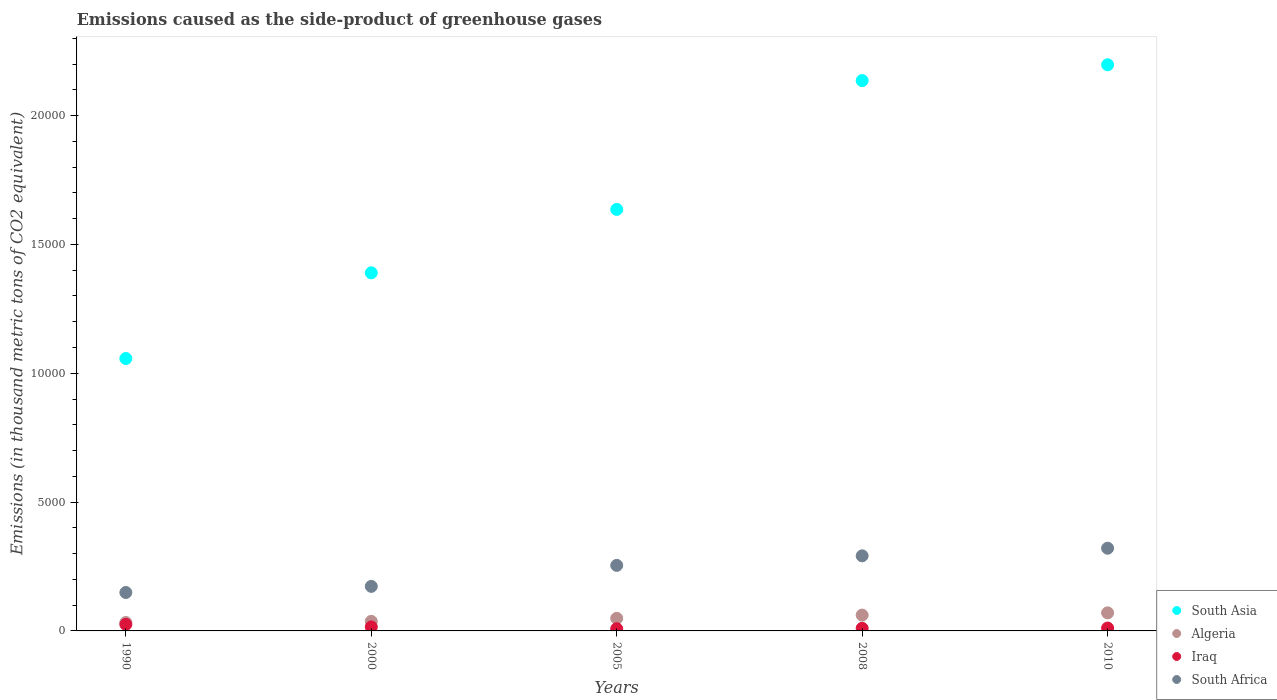Is the number of dotlines equal to the number of legend labels?
Provide a succinct answer. Yes. What is the emissions caused as the side-product of greenhouse gases in Algeria in 2000?
Give a very brief answer. 371.9. Across all years, what is the maximum emissions caused as the side-product of greenhouse gases in South Africa?
Your response must be concise. 3210. Across all years, what is the minimum emissions caused as the side-product of greenhouse gases in South Asia?
Your response must be concise. 1.06e+04. In which year was the emissions caused as the side-product of greenhouse gases in Algeria maximum?
Provide a succinct answer. 2010. In which year was the emissions caused as the side-product of greenhouse gases in Iraq minimum?
Your answer should be very brief. 2005. What is the total emissions caused as the side-product of greenhouse gases in Iraq in the graph?
Ensure brevity in your answer.  708.7. What is the difference between the emissions caused as the side-product of greenhouse gases in Iraq in 2000 and that in 2008?
Keep it short and to the point. 54.4. What is the difference between the emissions caused as the side-product of greenhouse gases in South Asia in 2005 and the emissions caused as the side-product of greenhouse gases in South Africa in 2010?
Your response must be concise. 1.31e+04. What is the average emissions caused as the side-product of greenhouse gases in South Asia per year?
Keep it short and to the point. 1.68e+04. In the year 1990, what is the difference between the emissions caused as the side-product of greenhouse gases in Algeria and emissions caused as the side-product of greenhouse gases in South Africa?
Keep it short and to the point. -1165.1. What is the ratio of the emissions caused as the side-product of greenhouse gases in Iraq in 2008 to that in 2010?
Your answer should be very brief. 0.91. Is the emissions caused as the side-product of greenhouse gases in South Asia in 2005 less than that in 2010?
Offer a very short reply. Yes. What is the difference between the highest and the second highest emissions caused as the side-product of greenhouse gases in Algeria?
Keep it short and to the point. 87.1. What is the difference between the highest and the lowest emissions caused as the side-product of greenhouse gases in South Africa?
Your response must be concise. 1718.9. Is it the case that in every year, the sum of the emissions caused as the side-product of greenhouse gases in Iraq and emissions caused as the side-product of greenhouse gases in South Asia  is greater than the emissions caused as the side-product of greenhouse gases in Algeria?
Provide a short and direct response. Yes. Does the emissions caused as the side-product of greenhouse gases in Algeria monotonically increase over the years?
Your answer should be very brief. Yes. Is the emissions caused as the side-product of greenhouse gases in South Asia strictly less than the emissions caused as the side-product of greenhouse gases in Algeria over the years?
Your response must be concise. No. How many dotlines are there?
Offer a terse response. 4. How many years are there in the graph?
Your answer should be very brief. 5. Are the values on the major ticks of Y-axis written in scientific E-notation?
Make the answer very short. No. Does the graph contain grids?
Offer a very short reply. No. How many legend labels are there?
Keep it short and to the point. 4. What is the title of the graph?
Your answer should be compact. Emissions caused as the side-product of greenhouse gases. What is the label or title of the X-axis?
Your answer should be compact. Years. What is the label or title of the Y-axis?
Make the answer very short. Emissions (in thousand metric tons of CO2 equivalent). What is the Emissions (in thousand metric tons of CO2 equivalent) in South Asia in 1990?
Your response must be concise. 1.06e+04. What is the Emissions (in thousand metric tons of CO2 equivalent) of Algeria in 1990?
Provide a short and direct response. 326. What is the Emissions (in thousand metric tons of CO2 equivalent) of Iraq in 1990?
Keep it short and to the point. 252.9. What is the Emissions (in thousand metric tons of CO2 equivalent) in South Africa in 1990?
Provide a short and direct response. 1491.1. What is the Emissions (in thousand metric tons of CO2 equivalent) of South Asia in 2000?
Offer a terse response. 1.39e+04. What is the Emissions (in thousand metric tons of CO2 equivalent) of Algeria in 2000?
Keep it short and to the point. 371.9. What is the Emissions (in thousand metric tons of CO2 equivalent) of Iraq in 2000?
Offer a terse response. 156.1. What is the Emissions (in thousand metric tons of CO2 equivalent) of South Africa in 2000?
Offer a terse response. 1728.8. What is the Emissions (in thousand metric tons of CO2 equivalent) of South Asia in 2005?
Provide a succinct answer. 1.64e+04. What is the Emissions (in thousand metric tons of CO2 equivalent) of Algeria in 2005?
Your answer should be compact. 487.4. What is the Emissions (in thousand metric tons of CO2 equivalent) of Iraq in 2005?
Make the answer very short. 86. What is the Emissions (in thousand metric tons of CO2 equivalent) of South Africa in 2005?
Your response must be concise. 2544. What is the Emissions (in thousand metric tons of CO2 equivalent) of South Asia in 2008?
Offer a terse response. 2.14e+04. What is the Emissions (in thousand metric tons of CO2 equivalent) in Algeria in 2008?
Offer a very short reply. 613.9. What is the Emissions (in thousand metric tons of CO2 equivalent) of Iraq in 2008?
Your response must be concise. 101.7. What is the Emissions (in thousand metric tons of CO2 equivalent) of South Africa in 2008?
Keep it short and to the point. 2914.4. What is the Emissions (in thousand metric tons of CO2 equivalent) of South Asia in 2010?
Offer a terse response. 2.20e+04. What is the Emissions (in thousand metric tons of CO2 equivalent) of Algeria in 2010?
Offer a terse response. 701. What is the Emissions (in thousand metric tons of CO2 equivalent) of Iraq in 2010?
Provide a succinct answer. 112. What is the Emissions (in thousand metric tons of CO2 equivalent) of South Africa in 2010?
Offer a terse response. 3210. Across all years, what is the maximum Emissions (in thousand metric tons of CO2 equivalent) in South Asia?
Your answer should be compact. 2.20e+04. Across all years, what is the maximum Emissions (in thousand metric tons of CO2 equivalent) of Algeria?
Offer a terse response. 701. Across all years, what is the maximum Emissions (in thousand metric tons of CO2 equivalent) of Iraq?
Keep it short and to the point. 252.9. Across all years, what is the maximum Emissions (in thousand metric tons of CO2 equivalent) of South Africa?
Your response must be concise. 3210. Across all years, what is the minimum Emissions (in thousand metric tons of CO2 equivalent) in South Asia?
Provide a short and direct response. 1.06e+04. Across all years, what is the minimum Emissions (in thousand metric tons of CO2 equivalent) in Algeria?
Your answer should be compact. 326. Across all years, what is the minimum Emissions (in thousand metric tons of CO2 equivalent) in Iraq?
Keep it short and to the point. 86. Across all years, what is the minimum Emissions (in thousand metric tons of CO2 equivalent) in South Africa?
Your answer should be very brief. 1491.1. What is the total Emissions (in thousand metric tons of CO2 equivalent) of South Asia in the graph?
Offer a terse response. 8.42e+04. What is the total Emissions (in thousand metric tons of CO2 equivalent) in Algeria in the graph?
Provide a succinct answer. 2500.2. What is the total Emissions (in thousand metric tons of CO2 equivalent) in Iraq in the graph?
Keep it short and to the point. 708.7. What is the total Emissions (in thousand metric tons of CO2 equivalent) of South Africa in the graph?
Offer a very short reply. 1.19e+04. What is the difference between the Emissions (in thousand metric tons of CO2 equivalent) in South Asia in 1990 and that in 2000?
Provide a short and direct response. -3325.3. What is the difference between the Emissions (in thousand metric tons of CO2 equivalent) of Algeria in 1990 and that in 2000?
Make the answer very short. -45.9. What is the difference between the Emissions (in thousand metric tons of CO2 equivalent) in Iraq in 1990 and that in 2000?
Keep it short and to the point. 96.8. What is the difference between the Emissions (in thousand metric tons of CO2 equivalent) in South Africa in 1990 and that in 2000?
Your answer should be compact. -237.7. What is the difference between the Emissions (in thousand metric tons of CO2 equivalent) in South Asia in 1990 and that in 2005?
Offer a very short reply. -5786.5. What is the difference between the Emissions (in thousand metric tons of CO2 equivalent) of Algeria in 1990 and that in 2005?
Keep it short and to the point. -161.4. What is the difference between the Emissions (in thousand metric tons of CO2 equivalent) of Iraq in 1990 and that in 2005?
Your answer should be compact. 166.9. What is the difference between the Emissions (in thousand metric tons of CO2 equivalent) in South Africa in 1990 and that in 2005?
Provide a succinct answer. -1052.9. What is the difference between the Emissions (in thousand metric tons of CO2 equivalent) of South Asia in 1990 and that in 2008?
Give a very brief answer. -1.08e+04. What is the difference between the Emissions (in thousand metric tons of CO2 equivalent) of Algeria in 1990 and that in 2008?
Provide a short and direct response. -287.9. What is the difference between the Emissions (in thousand metric tons of CO2 equivalent) of Iraq in 1990 and that in 2008?
Your answer should be compact. 151.2. What is the difference between the Emissions (in thousand metric tons of CO2 equivalent) of South Africa in 1990 and that in 2008?
Make the answer very short. -1423.3. What is the difference between the Emissions (in thousand metric tons of CO2 equivalent) in South Asia in 1990 and that in 2010?
Give a very brief answer. -1.14e+04. What is the difference between the Emissions (in thousand metric tons of CO2 equivalent) in Algeria in 1990 and that in 2010?
Offer a terse response. -375. What is the difference between the Emissions (in thousand metric tons of CO2 equivalent) of Iraq in 1990 and that in 2010?
Give a very brief answer. 140.9. What is the difference between the Emissions (in thousand metric tons of CO2 equivalent) of South Africa in 1990 and that in 2010?
Provide a short and direct response. -1718.9. What is the difference between the Emissions (in thousand metric tons of CO2 equivalent) of South Asia in 2000 and that in 2005?
Your answer should be compact. -2461.2. What is the difference between the Emissions (in thousand metric tons of CO2 equivalent) of Algeria in 2000 and that in 2005?
Your response must be concise. -115.5. What is the difference between the Emissions (in thousand metric tons of CO2 equivalent) of Iraq in 2000 and that in 2005?
Make the answer very short. 70.1. What is the difference between the Emissions (in thousand metric tons of CO2 equivalent) in South Africa in 2000 and that in 2005?
Ensure brevity in your answer.  -815.2. What is the difference between the Emissions (in thousand metric tons of CO2 equivalent) in South Asia in 2000 and that in 2008?
Offer a terse response. -7460.6. What is the difference between the Emissions (in thousand metric tons of CO2 equivalent) in Algeria in 2000 and that in 2008?
Offer a very short reply. -242. What is the difference between the Emissions (in thousand metric tons of CO2 equivalent) in Iraq in 2000 and that in 2008?
Provide a short and direct response. 54.4. What is the difference between the Emissions (in thousand metric tons of CO2 equivalent) of South Africa in 2000 and that in 2008?
Your response must be concise. -1185.6. What is the difference between the Emissions (in thousand metric tons of CO2 equivalent) in South Asia in 2000 and that in 2010?
Offer a very short reply. -8075.1. What is the difference between the Emissions (in thousand metric tons of CO2 equivalent) of Algeria in 2000 and that in 2010?
Keep it short and to the point. -329.1. What is the difference between the Emissions (in thousand metric tons of CO2 equivalent) of Iraq in 2000 and that in 2010?
Give a very brief answer. 44.1. What is the difference between the Emissions (in thousand metric tons of CO2 equivalent) in South Africa in 2000 and that in 2010?
Offer a very short reply. -1481.2. What is the difference between the Emissions (in thousand metric tons of CO2 equivalent) of South Asia in 2005 and that in 2008?
Offer a terse response. -4999.4. What is the difference between the Emissions (in thousand metric tons of CO2 equivalent) of Algeria in 2005 and that in 2008?
Your answer should be compact. -126.5. What is the difference between the Emissions (in thousand metric tons of CO2 equivalent) of Iraq in 2005 and that in 2008?
Your answer should be compact. -15.7. What is the difference between the Emissions (in thousand metric tons of CO2 equivalent) in South Africa in 2005 and that in 2008?
Provide a succinct answer. -370.4. What is the difference between the Emissions (in thousand metric tons of CO2 equivalent) in South Asia in 2005 and that in 2010?
Your answer should be compact. -5613.9. What is the difference between the Emissions (in thousand metric tons of CO2 equivalent) of Algeria in 2005 and that in 2010?
Offer a terse response. -213.6. What is the difference between the Emissions (in thousand metric tons of CO2 equivalent) of South Africa in 2005 and that in 2010?
Make the answer very short. -666. What is the difference between the Emissions (in thousand metric tons of CO2 equivalent) of South Asia in 2008 and that in 2010?
Your answer should be very brief. -614.5. What is the difference between the Emissions (in thousand metric tons of CO2 equivalent) of Algeria in 2008 and that in 2010?
Your answer should be compact. -87.1. What is the difference between the Emissions (in thousand metric tons of CO2 equivalent) of Iraq in 2008 and that in 2010?
Provide a succinct answer. -10.3. What is the difference between the Emissions (in thousand metric tons of CO2 equivalent) of South Africa in 2008 and that in 2010?
Your answer should be compact. -295.6. What is the difference between the Emissions (in thousand metric tons of CO2 equivalent) of South Asia in 1990 and the Emissions (in thousand metric tons of CO2 equivalent) of Algeria in 2000?
Your answer should be compact. 1.02e+04. What is the difference between the Emissions (in thousand metric tons of CO2 equivalent) in South Asia in 1990 and the Emissions (in thousand metric tons of CO2 equivalent) in Iraq in 2000?
Provide a short and direct response. 1.04e+04. What is the difference between the Emissions (in thousand metric tons of CO2 equivalent) in South Asia in 1990 and the Emissions (in thousand metric tons of CO2 equivalent) in South Africa in 2000?
Provide a succinct answer. 8843.8. What is the difference between the Emissions (in thousand metric tons of CO2 equivalent) in Algeria in 1990 and the Emissions (in thousand metric tons of CO2 equivalent) in Iraq in 2000?
Ensure brevity in your answer.  169.9. What is the difference between the Emissions (in thousand metric tons of CO2 equivalent) of Algeria in 1990 and the Emissions (in thousand metric tons of CO2 equivalent) of South Africa in 2000?
Keep it short and to the point. -1402.8. What is the difference between the Emissions (in thousand metric tons of CO2 equivalent) in Iraq in 1990 and the Emissions (in thousand metric tons of CO2 equivalent) in South Africa in 2000?
Keep it short and to the point. -1475.9. What is the difference between the Emissions (in thousand metric tons of CO2 equivalent) of South Asia in 1990 and the Emissions (in thousand metric tons of CO2 equivalent) of Algeria in 2005?
Provide a succinct answer. 1.01e+04. What is the difference between the Emissions (in thousand metric tons of CO2 equivalent) in South Asia in 1990 and the Emissions (in thousand metric tons of CO2 equivalent) in Iraq in 2005?
Your response must be concise. 1.05e+04. What is the difference between the Emissions (in thousand metric tons of CO2 equivalent) in South Asia in 1990 and the Emissions (in thousand metric tons of CO2 equivalent) in South Africa in 2005?
Your answer should be very brief. 8028.6. What is the difference between the Emissions (in thousand metric tons of CO2 equivalent) in Algeria in 1990 and the Emissions (in thousand metric tons of CO2 equivalent) in Iraq in 2005?
Your answer should be compact. 240. What is the difference between the Emissions (in thousand metric tons of CO2 equivalent) in Algeria in 1990 and the Emissions (in thousand metric tons of CO2 equivalent) in South Africa in 2005?
Ensure brevity in your answer.  -2218. What is the difference between the Emissions (in thousand metric tons of CO2 equivalent) of Iraq in 1990 and the Emissions (in thousand metric tons of CO2 equivalent) of South Africa in 2005?
Offer a very short reply. -2291.1. What is the difference between the Emissions (in thousand metric tons of CO2 equivalent) in South Asia in 1990 and the Emissions (in thousand metric tons of CO2 equivalent) in Algeria in 2008?
Your answer should be very brief. 9958.7. What is the difference between the Emissions (in thousand metric tons of CO2 equivalent) of South Asia in 1990 and the Emissions (in thousand metric tons of CO2 equivalent) of Iraq in 2008?
Provide a succinct answer. 1.05e+04. What is the difference between the Emissions (in thousand metric tons of CO2 equivalent) of South Asia in 1990 and the Emissions (in thousand metric tons of CO2 equivalent) of South Africa in 2008?
Provide a short and direct response. 7658.2. What is the difference between the Emissions (in thousand metric tons of CO2 equivalent) of Algeria in 1990 and the Emissions (in thousand metric tons of CO2 equivalent) of Iraq in 2008?
Ensure brevity in your answer.  224.3. What is the difference between the Emissions (in thousand metric tons of CO2 equivalent) in Algeria in 1990 and the Emissions (in thousand metric tons of CO2 equivalent) in South Africa in 2008?
Provide a succinct answer. -2588.4. What is the difference between the Emissions (in thousand metric tons of CO2 equivalent) in Iraq in 1990 and the Emissions (in thousand metric tons of CO2 equivalent) in South Africa in 2008?
Give a very brief answer. -2661.5. What is the difference between the Emissions (in thousand metric tons of CO2 equivalent) of South Asia in 1990 and the Emissions (in thousand metric tons of CO2 equivalent) of Algeria in 2010?
Offer a terse response. 9871.6. What is the difference between the Emissions (in thousand metric tons of CO2 equivalent) in South Asia in 1990 and the Emissions (in thousand metric tons of CO2 equivalent) in Iraq in 2010?
Make the answer very short. 1.05e+04. What is the difference between the Emissions (in thousand metric tons of CO2 equivalent) of South Asia in 1990 and the Emissions (in thousand metric tons of CO2 equivalent) of South Africa in 2010?
Your response must be concise. 7362.6. What is the difference between the Emissions (in thousand metric tons of CO2 equivalent) in Algeria in 1990 and the Emissions (in thousand metric tons of CO2 equivalent) in Iraq in 2010?
Offer a terse response. 214. What is the difference between the Emissions (in thousand metric tons of CO2 equivalent) of Algeria in 1990 and the Emissions (in thousand metric tons of CO2 equivalent) of South Africa in 2010?
Give a very brief answer. -2884. What is the difference between the Emissions (in thousand metric tons of CO2 equivalent) of Iraq in 1990 and the Emissions (in thousand metric tons of CO2 equivalent) of South Africa in 2010?
Ensure brevity in your answer.  -2957.1. What is the difference between the Emissions (in thousand metric tons of CO2 equivalent) in South Asia in 2000 and the Emissions (in thousand metric tons of CO2 equivalent) in Algeria in 2005?
Your answer should be compact. 1.34e+04. What is the difference between the Emissions (in thousand metric tons of CO2 equivalent) in South Asia in 2000 and the Emissions (in thousand metric tons of CO2 equivalent) in Iraq in 2005?
Your answer should be compact. 1.38e+04. What is the difference between the Emissions (in thousand metric tons of CO2 equivalent) of South Asia in 2000 and the Emissions (in thousand metric tons of CO2 equivalent) of South Africa in 2005?
Give a very brief answer. 1.14e+04. What is the difference between the Emissions (in thousand metric tons of CO2 equivalent) of Algeria in 2000 and the Emissions (in thousand metric tons of CO2 equivalent) of Iraq in 2005?
Ensure brevity in your answer.  285.9. What is the difference between the Emissions (in thousand metric tons of CO2 equivalent) in Algeria in 2000 and the Emissions (in thousand metric tons of CO2 equivalent) in South Africa in 2005?
Your response must be concise. -2172.1. What is the difference between the Emissions (in thousand metric tons of CO2 equivalent) in Iraq in 2000 and the Emissions (in thousand metric tons of CO2 equivalent) in South Africa in 2005?
Your response must be concise. -2387.9. What is the difference between the Emissions (in thousand metric tons of CO2 equivalent) of South Asia in 2000 and the Emissions (in thousand metric tons of CO2 equivalent) of Algeria in 2008?
Keep it short and to the point. 1.33e+04. What is the difference between the Emissions (in thousand metric tons of CO2 equivalent) in South Asia in 2000 and the Emissions (in thousand metric tons of CO2 equivalent) in Iraq in 2008?
Your answer should be very brief. 1.38e+04. What is the difference between the Emissions (in thousand metric tons of CO2 equivalent) in South Asia in 2000 and the Emissions (in thousand metric tons of CO2 equivalent) in South Africa in 2008?
Your answer should be very brief. 1.10e+04. What is the difference between the Emissions (in thousand metric tons of CO2 equivalent) in Algeria in 2000 and the Emissions (in thousand metric tons of CO2 equivalent) in Iraq in 2008?
Your answer should be compact. 270.2. What is the difference between the Emissions (in thousand metric tons of CO2 equivalent) in Algeria in 2000 and the Emissions (in thousand metric tons of CO2 equivalent) in South Africa in 2008?
Your response must be concise. -2542.5. What is the difference between the Emissions (in thousand metric tons of CO2 equivalent) in Iraq in 2000 and the Emissions (in thousand metric tons of CO2 equivalent) in South Africa in 2008?
Your answer should be compact. -2758.3. What is the difference between the Emissions (in thousand metric tons of CO2 equivalent) of South Asia in 2000 and the Emissions (in thousand metric tons of CO2 equivalent) of Algeria in 2010?
Your answer should be compact. 1.32e+04. What is the difference between the Emissions (in thousand metric tons of CO2 equivalent) of South Asia in 2000 and the Emissions (in thousand metric tons of CO2 equivalent) of Iraq in 2010?
Keep it short and to the point. 1.38e+04. What is the difference between the Emissions (in thousand metric tons of CO2 equivalent) in South Asia in 2000 and the Emissions (in thousand metric tons of CO2 equivalent) in South Africa in 2010?
Your response must be concise. 1.07e+04. What is the difference between the Emissions (in thousand metric tons of CO2 equivalent) in Algeria in 2000 and the Emissions (in thousand metric tons of CO2 equivalent) in Iraq in 2010?
Keep it short and to the point. 259.9. What is the difference between the Emissions (in thousand metric tons of CO2 equivalent) in Algeria in 2000 and the Emissions (in thousand metric tons of CO2 equivalent) in South Africa in 2010?
Make the answer very short. -2838.1. What is the difference between the Emissions (in thousand metric tons of CO2 equivalent) of Iraq in 2000 and the Emissions (in thousand metric tons of CO2 equivalent) of South Africa in 2010?
Offer a terse response. -3053.9. What is the difference between the Emissions (in thousand metric tons of CO2 equivalent) of South Asia in 2005 and the Emissions (in thousand metric tons of CO2 equivalent) of Algeria in 2008?
Your answer should be very brief. 1.57e+04. What is the difference between the Emissions (in thousand metric tons of CO2 equivalent) in South Asia in 2005 and the Emissions (in thousand metric tons of CO2 equivalent) in Iraq in 2008?
Offer a very short reply. 1.63e+04. What is the difference between the Emissions (in thousand metric tons of CO2 equivalent) in South Asia in 2005 and the Emissions (in thousand metric tons of CO2 equivalent) in South Africa in 2008?
Keep it short and to the point. 1.34e+04. What is the difference between the Emissions (in thousand metric tons of CO2 equivalent) of Algeria in 2005 and the Emissions (in thousand metric tons of CO2 equivalent) of Iraq in 2008?
Ensure brevity in your answer.  385.7. What is the difference between the Emissions (in thousand metric tons of CO2 equivalent) of Algeria in 2005 and the Emissions (in thousand metric tons of CO2 equivalent) of South Africa in 2008?
Keep it short and to the point. -2427. What is the difference between the Emissions (in thousand metric tons of CO2 equivalent) of Iraq in 2005 and the Emissions (in thousand metric tons of CO2 equivalent) of South Africa in 2008?
Your answer should be compact. -2828.4. What is the difference between the Emissions (in thousand metric tons of CO2 equivalent) in South Asia in 2005 and the Emissions (in thousand metric tons of CO2 equivalent) in Algeria in 2010?
Give a very brief answer. 1.57e+04. What is the difference between the Emissions (in thousand metric tons of CO2 equivalent) in South Asia in 2005 and the Emissions (in thousand metric tons of CO2 equivalent) in Iraq in 2010?
Provide a succinct answer. 1.62e+04. What is the difference between the Emissions (in thousand metric tons of CO2 equivalent) in South Asia in 2005 and the Emissions (in thousand metric tons of CO2 equivalent) in South Africa in 2010?
Make the answer very short. 1.31e+04. What is the difference between the Emissions (in thousand metric tons of CO2 equivalent) of Algeria in 2005 and the Emissions (in thousand metric tons of CO2 equivalent) of Iraq in 2010?
Offer a very short reply. 375.4. What is the difference between the Emissions (in thousand metric tons of CO2 equivalent) in Algeria in 2005 and the Emissions (in thousand metric tons of CO2 equivalent) in South Africa in 2010?
Ensure brevity in your answer.  -2722.6. What is the difference between the Emissions (in thousand metric tons of CO2 equivalent) in Iraq in 2005 and the Emissions (in thousand metric tons of CO2 equivalent) in South Africa in 2010?
Give a very brief answer. -3124. What is the difference between the Emissions (in thousand metric tons of CO2 equivalent) in South Asia in 2008 and the Emissions (in thousand metric tons of CO2 equivalent) in Algeria in 2010?
Offer a terse response. 2.07e+04. What is the difference between the Emissions (in thousand metric tons of CO2 equivalent) in South Asia in 2008 and the Emissions (in thousand metric tons of CO2 equivalent) in Iraq in 2010?
Offer a terse response. 2.12e+04. What is the difference between the Emissions (in thousand metric tons of CO2 equivalent) of South Asia in 2008 and the Emissions (in thousand metric tons of CO2 equivalent) of South Africa in 2010?
Your answer should be very brief. 1.81e+04. What is the difference between the Emissions (in thousand metric tons of CO2 equivalent) in Algeria in 2008 and the Emissions (in thousand metric tons of CO2 equivalent) in Iraq in 2010?
Offer a terse response. 501.9. What is the difference between the Emissions (in thousand metric tons of CO2 equivalent) in Algeria in 2008 and the Emissions (in thousand metric tons of CO2 equivalent) in South Africa in 2010?
Offer a very short reply. -2596.1. What is the difference between the Emissions (in thousand metric tons of CO2 equivalent) in Iraq in 2008 and the Emissions (in thousand metric tons of CO2 equivalent) in South Africa in 2010?
Your answer should be compact. -3108.3. What is the average Emissions (in thousand metric tons of CO2 equivalent) of South Asia per year?
Keep it short and to the point. 1.68e+04. What is the average Emissions (in thousand metric tons of CO2 equivalent) of Algeria per year?
Provide a succinct answer. 500.04. What is the average Emissions (in thousand metric tons of CO2 equivalent) of Iraq per year?
Provide a short and direct response. 141.74. What is the average Emissions (in thousand metric tons of CO2 equivalent) in South Africa per year?
Keep it short and to the point. 2377.66. In the year 1990, what is the difference between the Emissions (in thousand metric tons of CO2 equivalent) in South Asia and Emissions (in thousand metric tons of CO2 equivalent) in Algeria?
Your answer should be very brief. 1.02e+04. In the year 1990, what is the difference between the Emissions (in thousand metric tons of CO2 equivalent) in South Asia and Emissions (in thousand metric tons of CO2 equivalent) in Iraq?
Make the answer very short. 1.03e+04. In the year 1990, what is the difference between the Emissions (in thousand metric tons of CO2 equivalent) of South Asia and Emissions (in thousand metric tons of CO2 equivalent) of South Africa?
Provide a short and direct response. 9081.5. In the year 1990, what is the difference between the Emissions (in thousand metric tons of CO2 equivalent) of Algeria and Emissions (in thousand metric tons of CO2 equivalent) of Iraq?
Ensure brevity in your answer.  73.1. In the year 1990, what is the difference between the Emissions (in thousand metric tons of CO2 equivalent) of Algeria and Emissions (in thousand metric tons of CO2 equivalent) of South Africa?
Offer a terse response. -1165.1. In the year 1990, what is the difference between the Emissions (in thousand metric tons of CO2 equivalent) in Iraq and Emissions (in thousand metric tons of CO2 equivalent) in South Africa?
Provide a succinct answer. -1238.2. In the year 2000, what is the difference between the Emissions (in thousand metric tons of CO2 equivalent) in South Asia and Emissions (in thousand metric tons of CO2 equivalent) in Algeria?
Your response must be concise. 1.35e+04. In the year 2000, what is the difference between the Emissions (in thousand metric tons of CO2 equivalent) of South Asia and Emissions (in thousand metric tons of CO2 equivalent) of Iraq?
Give a very brief answer. 1.37e+04. In the year 2000, what is the difference between the Emissions (in thousand metric tons of CO2 equivalent) in South Asia and Emissions (in thousand metric tons of CO2 equivalent) in South Africa?
Ensure brevity in your answer.  1.22e+04. In the year 2000, what is the difference between the Emissions (in thousand metric tons of CO2 equivalent) in Algeria and Emissions (in thousand metric tons of CO2 equivalent) in Iraq?
Keep it short and to the point. 215.8. In the year 2000, what is the difference between the Emissions (in thousand metric tons of CO2 equivalent) in Algeria and Emissions (in thousand metric tons of CO2 equivalent) in South Africa?
Your answer should be compact. -1356.9. In the year 2000, what is the difference between the Emissions (in thousand metric tons of CO2 equivalent) of Iraq and Emissions (in thousand metric tons of CO2 equivalent) of South Africa?
Provide a short and direct response. -1572.7. In the year 2005, what is the difference between the Emissions (in thousand metric tons of CO2 equivalent) of South Asia and Emissions (in thousand metric tons of CO2 equivalent) of Algeria?
Ensure brevity in your answer.  1.59e+04. In the year 2005, what is the difference between the Emissions (in thousand metric tons of CO2 equivalent) in South Asia and Emissions (in thousand metric tons of CO2 equivalent) in Iraq?
Make the answer very short. 1.63e+04. In the year 2005, what is the difference between the Emissions (in thousand metric tons of CO2 equivalent) of South Asia and Emissions (in thousand metric tons of CO2 equivalent) of South Africa?
Offer a terse response. 1.38e+04. In the year 2005, what is the difference between the Emissions (in thousand metric tons of CO2 equivalent) in Algeria and Emissions (in thousand metric tons of CO2 equivalent) in Iraq?
Your answer should be very brief. 401.4. In the year 2005, what is the difference between the Emissions (in thousand metric tons of CO2 equivalent) of Algeria and Emissions (in thousand metric tons of CO2 equivalent) of South Africa?
Your answer should be very brief. -2056.6. In the year 2005, what is the difference between the Emissions (in thousand metric tons of CO2 equivalent) in Iraq and Emissions (in thousand metric tons of CO2 equivalent) in South Africa?
Keep it short and to the point. -2458. In the year 2008, what is the difference between the Emissions (in thousand metric tons of CO2 equivalent) in South Asia and Emissions (in thousand metric tons of CO2 equivalent) in Algeria?
Keep it short and to the point. 2.07e+04. In the year 2008, what is the difference between the Emissions (in thousand metric tons of CO2 equivalent) of South Asia and Emissions (in thousand metric tons of CO2 equivalent) of Iraq?
Offer a very short reply. 2.13e+04. In the year 2008, what is the difference between the Emissions (in thousand metric tons of CO2 equivalent) of South Asia and Emissions (in thousand metric tons of CO2 equivalent) of South Africa?
Ensure brevity in your answer.  1.84e+04. In the year 2008, what is the difference between the Emissions (in thousand metric tons of CO2 equivalent) of Algeria and Emissions (in thousand metric tons of CO2 equivalent) of Iraq?
Provide a succinct answer. 512.2. In the year 2008, what is the difference between the Emissions (in thousand metric tons of CO2 equivalent) of Algeria and Emissions (in thousand metric tons of CO2 equivalent) of South Africa?
Give a very brief answer. -2300.5. In the year 2008, what is the difference between the Emissions (in thousand metric tons of CO2 equivalent) in Iraq and Emissions (in thousand metric tons of CO2 equivalent) in South Africa?
Your answer should be compact. -2812.7. In the year 2010, what is the difference between the Emissions (in thousand metric tons of CO2 equivalent) in South Asia and Emissions (in thousand metric tons of CO2 equivalent) in Algeria?
Your response must be concise. 2.13e+04. In the year 2010, what is the difference between the Emissions (in thousand metric tons of CO2 equivalent) of South Asia and Emissions (in thousand metric tons of CO2 equivalent) of Iraq?
Ensure brevity in your answer.  2.19e+04. In the year 2010, what is the difference between the Emissions (in thousand metric tons of CO2 equivalent) of South Asia and Emissions (in thousand metric tons of CO2 equivalent) of South Africa?
Provide a succinct answer. 1.88e+04. In the year 2010, what is the difference between the Emissions (in thousand metric tons of CO2 equivalent) in Algeria and Emissions (in thousand metric tons of CO2 equivalent) in Iraq?
Make the answer very short. 589. In the year 2010, what is the difference between the Emissions (in thousand metric tons of CO2 equivalent) of Algeria and Emissions (in thousand metric tons of CO2 equivalent) of South Africa?
Your response must be concise. -2509. In the year 2010, what is the difference between the Emissions (in thousand metric tons of CO2 equivalent) in Iraq and Emissions (in thousand metric tons of CO2 equivalent) in South Africa?
Make the answer very short. -3098. What is the ratio of the Emissions (in thousand metric tons of CO2 equivalent) of South Asia in 1990 to that in 2000?
Your answer should be very brief. 0.76. What is the ratio of the Emissions (in thousand metric tons of CO2 equivalent) in Algeria in 1990 to that in 2000?
Your response must be concise. 0.88. What is the ratio of the Emissions (in thousand metric tons of CO2 equivalent) of Iraq in 1990 to that in 2000?
Provide a succinct answer. 1.62. What is the ratio of the Emissions (in thousand metric tons of CO2 equivalent) in South Africa in 1990 to that in 2000?
Make the answer very short. 0.86. What is the ratio of the Emissions (in thousand metric tons of CO2 equivalent) in South Asia in 1990 to that in 2005?
Ensure brevity in your answer.  0.65. What is the ratio of the Emissions (in thousand metric tons of CO2 equivalent) in Algeria in 1990 to that in 2005?
Ensure brevity in your answer.  0.67. What is the ratio of the Emissions (in thousand metric tons of CO2 equivalent) of Iraq in 1990 to that in 2005?
Your response must be concise. 2.94. What is the ratio of the Emissions (in thousand metric tons of CO2 equivalent) in South Africa in 1990 to that in 2005?
Keep it short and to the point. 0.59. What is the ratio of the Emissions (in thousand metric tons of CO2 equivalent) in South Asia in 1990 to that in 2008?
Your answer should be very brief. 0.49. What is the ratio of the Emissions (in thousand metric tons of CO2 equivalent) of Algeria in 1990 to that in 2008?
Make the answer very short. 0.53. What is the ratio of the Emissions (in thousand metric tons of CO2 equivalent) in Iraq in 1990 to that in 2008?
Offer a terse response. 2.49. What is the ratio of the Emissions (in thousand metric tons of CO2 equivalent) in South Africa in 1990 to that in 2008?
Offer a very short reply. 0.51. What is the ratio of the Emissions (in thousand metric tons of CO2 equivalent) of South Asia in 1990 to that in 2010?
Provide a short and direct response. 0.48. What is the ratio of the Emissions (in thousand metric tons of CO2 equivalent) of Algeria in 1990 to that in 2010?
Make the answer very short. 0.47. What is the ratio of the Emissions (in thousand metric tons of CO2 equivalent) in Iraq in 1990 to that in 2010?
Your answer should be very brief. 2.26. What is the ratio of the Emissions (in thousand metric tons of CO2 equivalent) in South Africa in 1990 to that in 2010?
Provide a short and direct response. 0.46. What is the ratio of the Emissions (in thousand metric tons of CO2 equivalent) in South Asia in 2000 to that in 2005?
Your response must be concise. 0.85. What is the ratio of the Emissions (in thousand metric tons of CO2 equivalent) of Algeria in 2000 to that in 2005?
Your response must be concise. 0.76. What is the ratio of the Emissions (in thousand metric tons of CO2 equivalent) of Iraq in 2000 to that in 2005?
Offer a very short reply. 1.82. What is the ratio of the Emissions (in thousand metric tons of CO2 equivalent) in South Africa in 2000 to that in 2005?
Offer a terse response. 0.68. What is the ratio of the Emissions (in thousand metric tons of CO2 equivalent) in South Asia in 2000 to that in 2008?
Offer a terse response. 0.65. What is the ratio of the Emissions (in thousand metric tons of CO2 equivalent) of Algeria in 2000 to that in 2008?
Provide a succinct answer. 0.61. What is the ratio of the Emissions (in thousand metric tons of CO2 equivalent) of Iraq in 2000 to that in 2008?
Offer a very short reply. 1.53. What is the ratio of the Emissions (in thousand metric tons of CO2 equivalent) in South Africa in 2000 to that in 2008?
Keep it short and to the point. 0.59. What is the ratio of the Emissions (in thousand metric tons of CO2 equivalent) in South Asia in 2000 to that in 2010?
Offer a very short reply. 0.63. What is the ratio of the Emissions (in thousand metric tons of CO2 equivalent) of Algeria in 2000 to that in 2010?
Your answer should be very brief. 0.53. What is the ratio of the Emissions (in thousand metric tons of CO2 equivalent) of Iraq in 2000 to that in 2010?
Your answer should be compact. 1.39. What is the ratio of the Emissions (in thousand metric tons of CO2 equivalent) of South Africa in 2000 to that in 2010?
Keep it short and to the point. 0.54. What is the ratio of the Emissions (in thousand metric tons of CO2 equivalent) in South Asia in 2005 to that in 2008?
Your response must be concise. 0.77. What is the ratio of the Emissions (in thousand metric tons of CO2 equivalent) in Algeria in 2005 to that in 2008?
Ensure brevity in your answer.  0.79. What is the ratio of the Emissions (in thousand metric tons of CO2 equivalent) in Iraq in 2005 to that in 2008?
Provide a succinct answer. 0.85. What is the ratio of the Emissions (in thousand metric tons of CO2 equivalent) in South Africa in 2005 to that in 2008?
Offer a very short reply. 0.87. What is the ratio of the Emissions (in thousand metric tons of CO2 equivalent) in South Asia in 2005 to that in 2010?
Provide a succinct answer. 0.74. What is the ratio of the Emissions (in thousand metric tons of CO2 equivalent) in Algeria in 2005 to that in 2010?
Make the answer very short. 0.7. What is the ratio of the Emissions (in thousand metric tons of CO2 equivalent) in Iraq in 2005 to that in 2010?
Give a very brief answer. 0.77. What is the ratio of the Emissions (in thousand metric tons of CO2 equivalent) in South Africa in 2005 to that in 2010?
Your answer should be compact. 0.79. What is the ratio of the Emissions (in thousand metric tons of CO2 equivalent) in South Asia in 2008 to that in 2010?
Your answer should be very brief. 0.97. What is the ratio of the Emissions (in thousand metric tons of CO2 equivalent) of Algeria in 2008 to that in 2010?
Ensure brevity in your answer.  0.88. What is the ratio of the Emissions (in thousand metric tons of CO2 equivalent) of Iraq in 2008 to that in 2010?
Ensure brevity in your answer.  0.91. What is the ratio of the Emissions (in thousand metric tons of CO2 equivalent) in South Africa in 2008 to that in 2010?
Keep it short and to the point. 0.91. What is the difference between the highest and the second highest Emissions (in thousand metric tons of CO2 equivalent) of South Asia?
Provide a short and direct response. 614.5. What is the difference between the highest and the second highest Emissions (in thousand metric tons of CO2 equivalent) of Algeria?
Make the answer very short. 87.1. What is the difference between the highest and the second highest Emissions (in thousand metric tons of CO2 equivalent) of Iraq?
Provide a short and direct response. 96.8. What is the difference between the highest and the second highest Emissions (in thousand metric tons of CO2 equivalent) of South Africa?
Provide a short and direct response. 295.6. What is the difference between the highest and the lowest Emissions (in thousand metric tons of CO2 equivalent) of South Asia?
Make the answer very short. 1.14e+04. What is the difference between the highest and the lowest Emissions (in thousand metric tons of CO2 equivalent) of Algeria?
Offer a very short reply. 375. What is the difference between the highest and the lowest Emissions (in thousand metric tons of CO2 equivalent) of Iraq?
Your response must be concise. 166.9. What is the difference between the highest and the lowest Emissions (in thousand metric tons of CO2 equivalent) in South Africa?
Your response must be concise. 1718.9. 